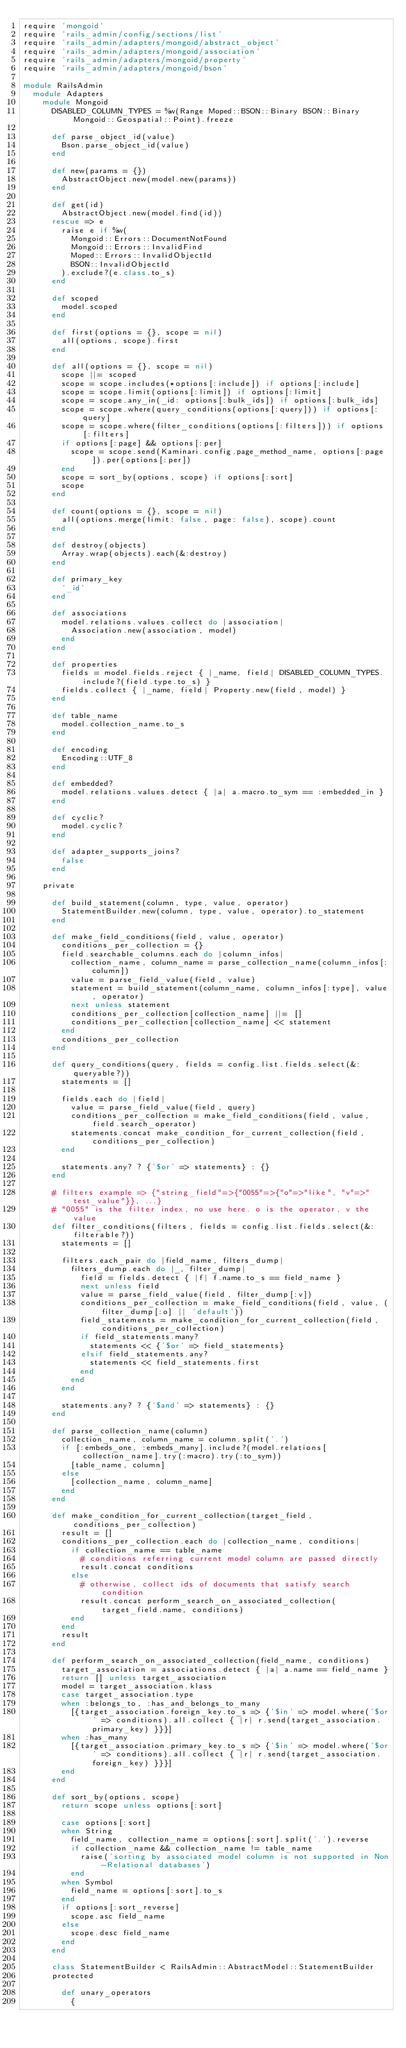<code> <loc_0><loc_0><loc_500><loc_500><_Ruby_>require 'mongoid'
require 'rails_admin/config/sections/list'
require 'rails_admin/adapters/mongoid/abstract_object'
require 'rails_admin/adapters/mongoid/association'
require 'rails_admin/adapters/mongoid/property'
require 'rails_admin/adapters/mongoid/bson'

module RailsAdmin
  module Adapters
    module Mongoid
      DISABLED_COLUMN_TYPES = %w(Range Moped::BSON::Binary BSON::Binary Mongoid::Geospatial::Point).freeze

      def parse_object_id(value)
        Bson.parse_object_id(value)
      end

      def new(params = {})
        AbstractObject.new(model.new(params))
      end

      def get(id)
        AbstractObject.new(model.find(id))
      rescue => e
        raise e if %w(
          Mongoid::Errors::DocumentNotFound
          Mongoid::Errors::InvalidFind
          Moped::Errors::InvalidObjectId
          BSON::InvalidObjectId
        ).exclude?(e.class.to_s)
      end

      def scoped
        model.scoped
      end

      def first(options = {}, scope = nil)
        all(options, scope).first
      end

      def all(options = {}, scope = nil)
        scope ||= scoped
        scope = scope.includes(*options[:include]) if options[:include]
        scope = scope.limit(options[:limit]) if options[:limit]
        scope = scope.any_in(_id: options[:bulk_ids]) if options[:bulk_ids]
        scope = scope.where(query_conditions(options[:query])) if options[:query]
        scope = scope.where(filter_conditions(options[:filters])) if options[:filters]
        if options[:page] && options[:per]
          scope = scope.send(Kaminari.config.page_method_name, options[:page]).per(options[:per])
        end
        scope = sort_by(options, scope) if options[:sort]
        scope
      end

      def count(options = {}, scope = nil)
        all(options.merge(limit: false, page: false), scope).count
      end

      def destroy(objects)
        Array.wrap(objects).each(&:destroy)
      end

      def primary_key
        '_id'
      end

      def associations
        model.relations.values.collect do |association|
          Association.new(association, model)
        end
      end

      def properties
        fields = model.fields.reject { |_name, field| DISABLED_COLUMN_TYPES.include?(field.type.to_s) }
        fields.collect { |_name, field| Property.new(field, model) }
      end

      def table_name
        model.collection_name.to_s
      end

      def encoding
        Encoding::UTF_8
      end

      def embedded?
        model.relations.values.detect { |a| a.macro.to_sym == :embedded_in }
      end

      def cyclic?
        model.cyclic?
      end

      def adapter_supports_joins?
        false
      end

    private

      def build_statement(column, type, value, operator)
        StatementBuilder.new(column, type, value, operator).to_statement
      end

      def make_field_conditions(field, value, operator)
        conditions_per_collection = {}
        field.searchable_columns.each do |column_infos|
          collection_name, column_name = parse_collection_name(column_infos[:column])
          value = parse_field_value(field, value)
          statement = build_statement(column_name, column_infos[:type], value, operator)
          next unless statement
          conditions_per_collection[collection_name] ||= []
          conditions_per_collection[collection_name] << statement
        end
        conditions_per_collection
      end

      def query_conditions(query, fields = config.list.fields.select(&:queryable?))
        statements = []

        fields.each do |field|
          value = parse_field_value(field, query)
          conditions_per_collection = make_field_conditions(field, value, field.search_operator)
          statements.concat make_condition_for_current_collection(field, conditions_per_collection)
        end

        statements.any? ? {'$or' => statements} : {}
      end

      # filters example => {"string_field"=>{"0055"=>{"o"=>"like", "v"=>"test_value"}}, ...}
      # "0055" is the filter index, no use here. o is the operator, v the value
      def filter_conditions(filters, fields = config.list.fields.select(&:filterable?))
        statements = []

        filters.each_pair do |field_name, filters_dump|
          filters_dump.each do |_, filter_dump|
            field = fields.detect { |f| f.name.to_s == field_name }
            next unless field
            value = parse_field_value(field, filter_dump[:v])
            conditions_per_collection = make_field_conditions(field, value, (filter_dump[:o] || 'default'))
            field_statements = make_condition_for_current_collection(field, conditions_per_collection)
            if field_statements.many?
              statements << {'$or' => field_statements}
            elsif field_statements.any?
              statements << field_statements.first
            end
          end
        end

        statements.any? ? {'$and' => statements} : {}
      end

      def parse_collection_name(column)
        collection_name, column_name = column.split('.')
        if [:embeds_one, :embeds_many].include?(model.relations[collection_name].try(:macro).try(:to_sym))
          [table_name, column]
        else
          [collection_name, column_name]
        end
      end

      def make_condition_for_current_collection(target_field, conditions_per_collection)
        result = []
        conditions_per_collection.each do |collection_name, conditions|
          if collection_name == table_name
            # conditions referring current model column are passed directly
            result.concat conditions
          else
            # otherwise, collect ids of documents that satisfy search condition
            result.concat perform_search_on_associated_collection(target_field.name, conditions)
          end
        end
        result
      end

      def perform_search_on_associated_collection(field_name, conditions)
        target_association = associations.detect { |a| a.name == field_name }
        return [] unless target_association
        model = target_association.klass
        case target_association.type
        when :belongs_to, :has_and_belongs_to_many
          [{target_association.foreign_key.to_s => {'$in' => model.where('$or' => conditions).all.collect { |r| r.send(target_association.primary_key) }}}]
        when :has_many
          [{target_association.primary_key.to_s => {'$in' => model.where('$or' => conditions).all.collect { |r| r.send(target_association.foreign_key) }}}]
        end
      end

      def sort_by(options, scope)
        return scope unless options[:sort]

        case options[:sort]
        when String
          field_name, collection_name = options[:sort].split('.').reverse
          if collection_name && collection_name != table_name
            raise('sorting by associated model column is not supported in Non-Relational databases')
          end
        when Symbol
          field_name = options[:sort].to_s
        end
        if options[:sort_reverse]
          scope.asc field_name
        else
          scope.desc field_name
        end
      end

      class StatementBuilder < RailsAdmin::AbstractModel::StatementBuilder
      protected

        def unary_operators
          {</code> 